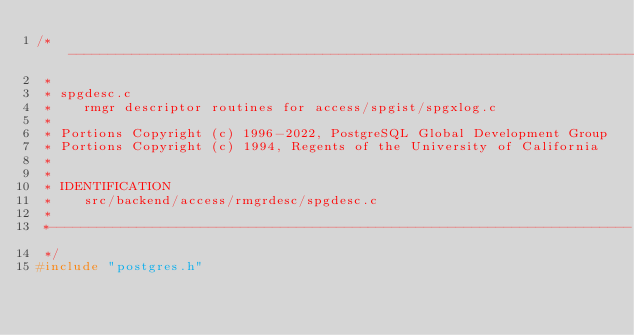<code> <loc_0><loc_0><loc_500><loc_500><_C_>/*-------------------------------------------------------------------------
 *
 * spgdesc.c
 *	  rmgr descriptor routines for access/spgist/spgxlog.c
 *
 * Portions Copyright (c) 1996-2022, PostgreSQL Global Development Group
 * Portions Copyright (c) 1994, Regents of the University of California
 *
 *
 * IDENTIFICATION
 *	  src/backend/access/rmgrdesc/spgdesc.c
 *
 *-------------------------------------------------------------------------
 */
#include "postgres.h"
</code> 